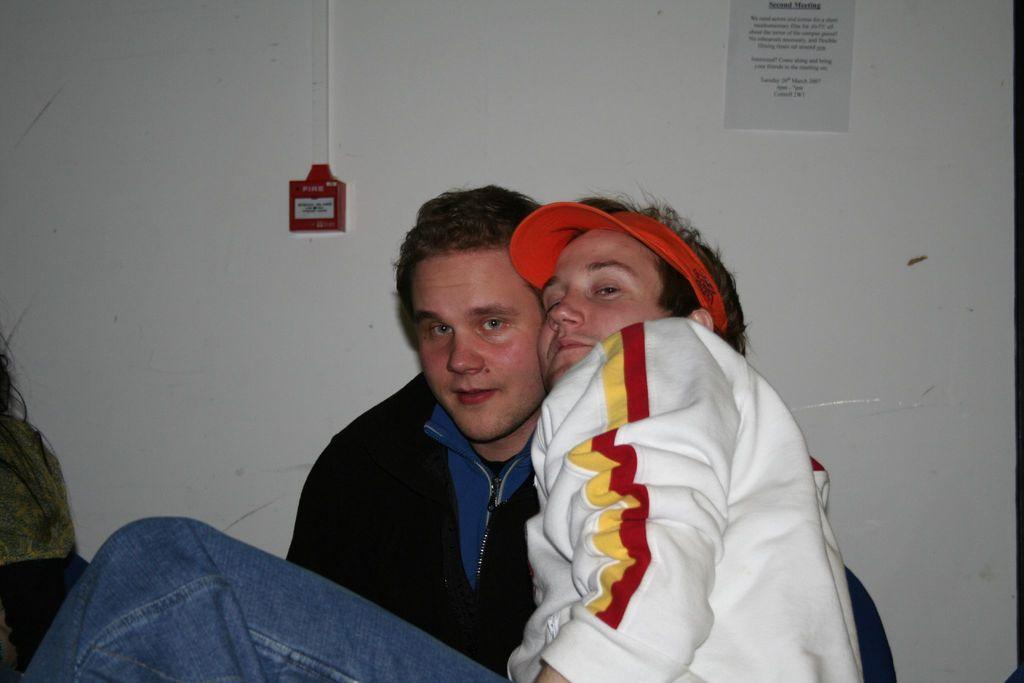What is the man in the middle of the image wearing? The man in the middle of the image is wearing a white color sweater. What is the other man beside him wearing? The other man beside him is wearing a black color sweater. What can be seen behind the two men? There is a wall visible behind the two men. How many babies are crawling on the wall behind the two men? There are no babies visible in the image, and the wall does not show any crawling babies. 